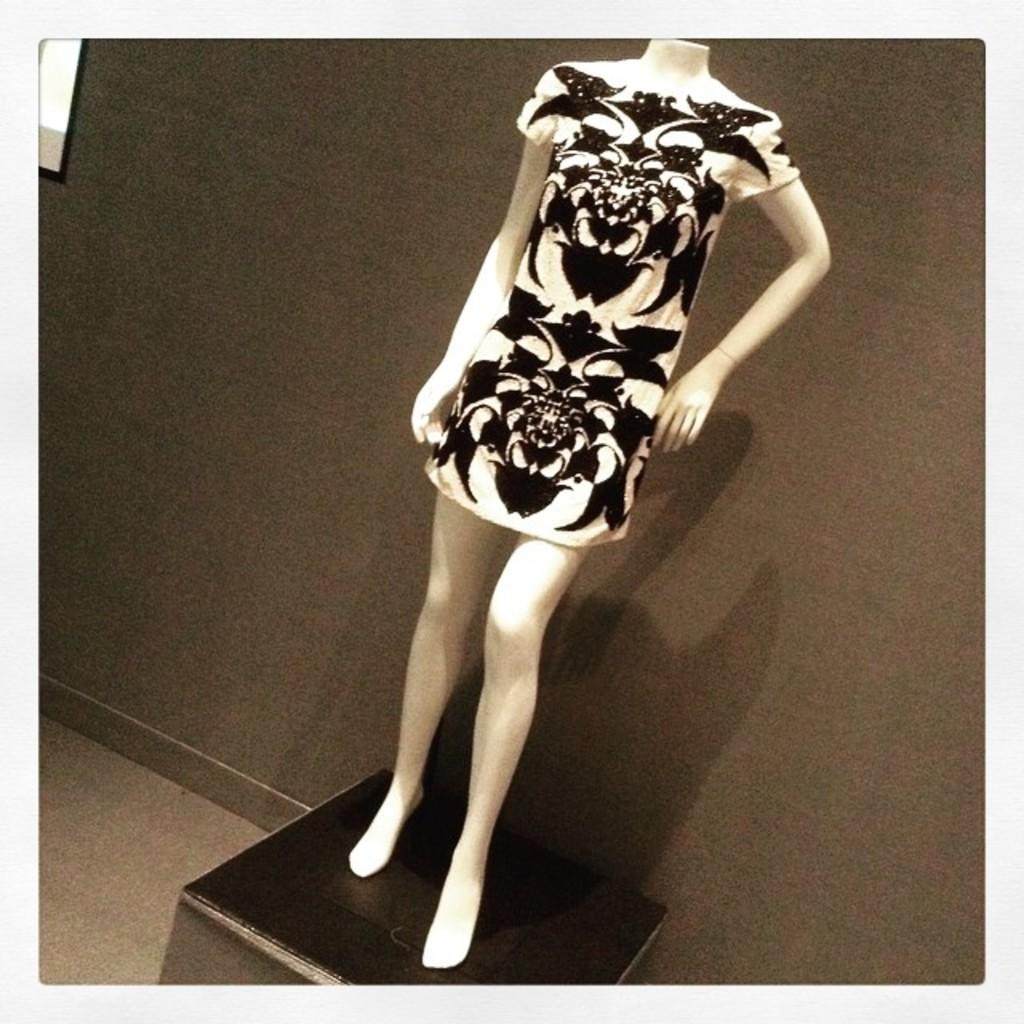What is the main subject of the image? There is a mannequin in the image. What is the mannequin wearing? The mannequin is wearing a black and white dress. Is there any accessory or object associated with the mannequin? Yes, there is a box associated with the mannequin. What can be seen in the background of the image? There is a wall in the background of the image. How many snails can be seen crawling on the mannequin's dress in the image? There are no snails present in the image, so it is not possible to determine how many might be crawling on the dress. 